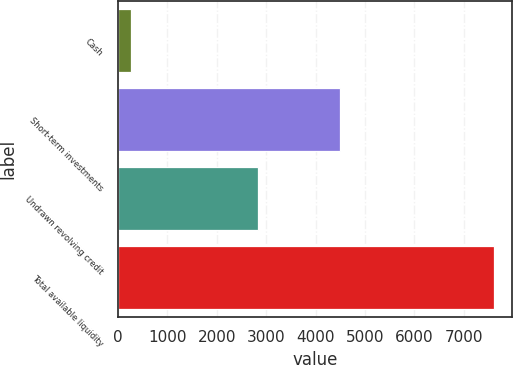Convert chart to OTSL. <chart><loc_0><loc_0><loc_500><loc_500><bar_chart><fcel>Cash<fcel>Short-term investments<fcel>Undrawn revolving credit<fcel>Total available liquidity<nl><fcel>275<fcel>4485<fcel>2843<fcel>7603<nl></chart> 